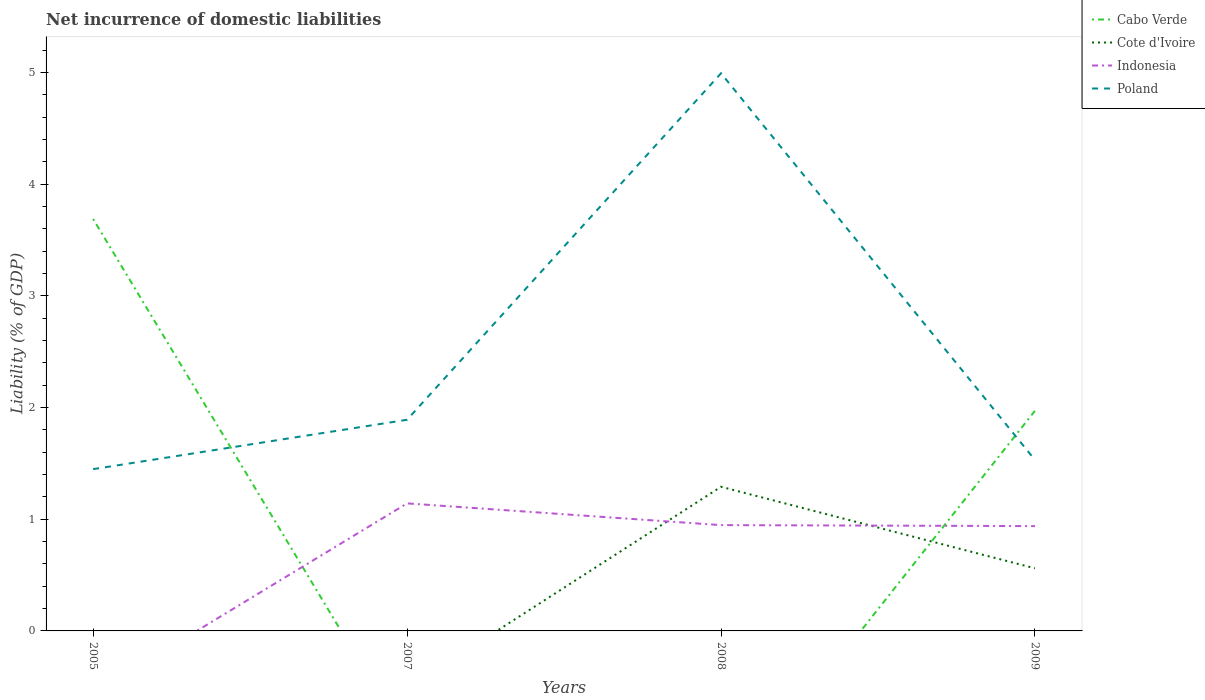How many different coloured lines are there?
Offer a terse response. 4. Is the number of lines equal to the number of legend labels?
Give a very brief answer. No. Across all years, what is the maximum net incurrence of domestic liabilities in Poland?
Make the answer very short. 1.45. What is the total net incurrence of domestic liabilities in Indonesia in the graph?
Your response must be concise. 0.19. What is the difference between the highest and the second highest net incurrence of domestic liabilities in Cote d'Ivoire?
Your answer should be very brief. 1.29. What is the difference between the highest and the lowest net incurrence of domestic liabilities in Cabo Verde?
Make the answer very short. 2. How many years are there in the graph?
Keep it short and to the point. 4. Does the graph contain grids?
Ensure brevity in your answer.  No. What is the title of the graph?
Give a very brief answer. Net incurrence of domestic liabilities. Does "Bangladesh" appear as one of the legend labels in the graph?
Provide a short and direct response. No. What is the label or title of the Y-axis?
Give a very brief answer. Liability (% of GDP). What is the Liability (% of GDP) in Cabo Verde in 2005?
Keep it short and to the point. 3.69. What is the Liability (% of GDP) of Indonesia in 2005?
Make the answer very short. 0. What is the Liability (% of GDP) in Poland in 2005?
Offer a terse response. 1.45. What is the Liability (% of GDP) of Indonesia in 2007?
Provide a succinct answer. 1.14. What is the Liability (% of GDP) in Poland in 2007?
Your answer should be compact. 1.89. What is the Liability (% of GDP) in Cabo Verde in 2008?
Give a very brief answer. 0. What is the Liability (% of GDP) of Cote d'Ivoire in 2008?
Offer a very short reply. 1.29. What is the Liability (% of GDP) in Indonesia in 2008?
Give a very brief answer. 0.95. What is the Liability (% of GDP) of Poland in 2008?
Keep it short and to the point. 4.99. What is the Liability (% of GDP) in Cabo Verde in 2009?
Your answer should be compact. 1.97. What is the Liability (% of GDP) of Cote d'Ivoire in 2009?
Provide a short and direct response. 0.56. What is the Liability (% of GDP) of Indonesia in 2009?
Make the answer very short. 0.94. What is the Liability (% of GDP) in Poland in 2009?
Provide a short and direct response. 1.53. Across all years, what is the maximum Liability (% of GDP) of Cabo Verde?
Keep it short and to the point. 3.69. Across all years, what is the maximum Liability (% of GDP) in Cote d'Ivoire?
Your answer should be compact. 1.29. Across all years, what is the maximum Liability (% of GDP) in Indonesia?
Your answer should be very brief. 1.14. Across all years, what is the maximum Liability (% of GDP) in Poland?
Provide a short and direct response. 4.99. Across all years, what is the minimum Liability (% of GDP) in Cote d'Ivoire?
Ensure brevity in your answer.  0. Across all years, what is the minimum Liability (% of GDP) of Indonesia?
Make the answer very short. 0. Across all years, what is the minimum Liability (% of GDP) in Poland?
Keep it short and to the point. 1.45. What is the total Liability (% of GDP) in Cabo Verde in the graph?
Offer a terse response. 5.66. What is the total Liability (% of GDP) of Cote d'Ivoire in the graph?
Provide a succinct answer. 1.85. What is the total Liability (% of GDP) in Indonesia in the graph?
Offer a very short reply. 3.03. What is the total Liability (% of GDP) in Poland in the graph?
Make the answer very short. 9.86. What is the difference between the Liability (% of GDP) in Poland in 2005 and that in 2007?
Your answer should be very brief. -0.44. What is the difference between the Liability (% of GDP) of Poland in 2005 and that in 2008?
Offer a terse response. -3.54. What is the difference between the Liability (% of GDP) of Cabo Verde in 2005 and that in 2009?
Ensure brevity in your answer.  1.72. What is the difference between the Liability (% of GDP) in Poland in 2005 and that in 2009?
Give a very brief answer. -0.08. What is the difference between the Liability (% of GDP) of Indonesia in 2007 and that in 2008?
Your response must be concise. 0.19. What is the difference between the Liability (% of GDP) in Poland in 2007 and that in 2008?
Provide a short and direct response. -3.1. What is the difference between the Liability (% of GDP) in Indonesia in 2007 and that in 2009?
Your answer should be compact. 0.2. What is the difference between the Liability (% of GDP) of Poland in 2007 and that in 2009?
Your response must be concise. 0.36. What is the difference between the Liability (% of GDP) in Cote d'Ivoire in 2008 and that in 2009?
Make the answer very short. 0.73. What is the difference between the Liability (% of GDP) in Indonesia in 2008 and that in 2009?
Your answer should be compact. 0.01. What is the difference between the Liability (% of GDP) in Poland in 2008 and that in 2009?
Give a very brief answer. 3.46. What is the difference between the Liability (% of GDP) of Cabo Verde in 2005 and the Liability (% of GDP) of Indonesia in 2007?
Provide a short and direct response. 2.55. What is the difference between the Liability (% of GDP) of Cabo Verde in 2005 and the Liability (% of GDP) of Poland in 2007?
Your answer should be very brief. 1.8. What is the difference between the Liability (% of GDP) in Cabo Verde in 2005 and the Liability (% of GDP) in Cote d'Ivoire in 2008?
Make the answer very short. 2.4. What is the difference between the Liability (% of GDP) in Cabo Verde in 2005 and the Liability (% of GDP) in Indonesia in 2008?
Keep it short and to the point. 2.74. What is the difference between the Liability (% of GDP) in Cabo Verde in 2005 and the Liability (% of GDP) in Poland in 2008?
Provide a short and direct response. -1.3. What is the difference between the Liability (% of GDP) in Cabo Verde in 2005 and the Liability (% of GDP) in Cote d'Ivoire in 2009?
Provide a short and direct response. 3.13. What is the difference between the Liability (% of GDP) in Cabo Verde in 2005 and the Liability (% of GDP) in Indonesia in 2009?
Keep it short and to the point. 2.75. What is the difference between the Liability (% of GDP) in Cabo Verde in 2005 and the Liability (% of GDP) in Poland in 2009?
Keep it short and to the point. 2.16. What is the difference between the Liability (% of GDP) of Indonesia in 2007 and the Liability (% of GDP) of Poland in 2008?
Your answer should be very brief. -3.85. What is the difference between the Liability (% of GDP) of Indonesia in 2007 and the Liability (% of GDP) of Poland in 2009?
Provide a succinct answer. -0.39. What is the difference between the Liability (% of GDP) in Cote d'Ivoire in 2008 and the Liability (% of GDP) in Indonesia in 2009?
Provide a short and direct response. 0.35. What is the difference between the Liability (% of GDP) of Cote d'Ivoire in 2008 and the Liability (% of GDP) of Poland in 2009?
Make the answer very short. -0.24. What is the difference between the Liability (% of GDP) in Indonesia in 2008 and the Liability (% of GDP) in Poland in 2009?
Ensure brevity in your answer.  -0.58. What is the average Liability (% of GDP) in Cabo Verde per year?
Your response must be concise. 1.41. What is the average Liability (% of GDP) in Cote d'Ivoire per year?
Keep it short and to the point. 0.46. What is the average Liability (% of GDP) in Indonesia per year?
Your response must be concise. 0.76. What is the average Liability (% of GDP) of Poland per year?
Provide a succinct answer. 2.47. In the year 2005, what is the difference between the Liability (% of GDP) of Cabo Verde and Liability (% of GDP) of Poland?
Your answer should be compact. 2.24. In the year 2007, what is the difference between the Liability (% of GDP) of Indonesia and Liability (% of GDP) of Poland?
Keep it short and to the point. -0.75. In the year 2008, what is the difference between the Liability (% of GDP) of Cote d'Ivoire and Liability (% of GDP) of Indonesia?
Your answer should be very brief. 0.34. In the year 2008, what is the difference between the Liability (% of GDP) of Cote d'Ivoire and Liability (% of GDP) of Poland?
Provide a succinct answer. -3.7. In the year 2008, what is the difference between the Liability (% of GDP) in Indonesia and Liability (% of GDP) in Poland?
Provide a succinct answer. -4.05. In the year 2009, what is the difference between the Liability (% of GDP) of Cabo Verde and Liability (% of GDP) of Cote d'Ivoire?
Your answer should be very brief. 1.41. In the year 2009, what is the difference between the Liability (% of GDP) of Cabo Verde and Liability (% of GDP) of Indonesia?
Provide a short and direct response. 1.03. In the year 2009, what is the difference between the Liability (% of GDP) in Cabo Verde and Liability (% of GDP) in Poland?
Your answer should be compact. 0.44. In the year 2009, what is the difference between the Liability (% of GDP) of Cote d'Ivoire and Liability (% of GDP) of Indonesia?
Your answer should be very brief. -0.38. In the year 2009, what is the difference between the Liability (% of GDP) in Cote d'Ivoire and Liability (% of GDP) in Poland?
Your answer should be compact. -0.97. In the year 2009, what is the difference between the Liability (% of GDP) of Indonesia and Liability (% of GDP) of Poland?
Your response must be concise. -0.59. What is the ratio of the Liability (% of GDP) in Poland in 2005 to that in 2007?
Offer a very short reply. 0.77. What is the ratio of the Liability (% of GDP) of Poland in 2005 to that in 2008?
Your response must be concise. 0.29. What is the ratio of the Liability (% of GDP) in Cabo Verde in 2005 to that in 2009?
Ensure brevity in your answer.  1.87. What is the ratio of the Liability (% of GDP) of Poland in 2005 to that in 2009?
Keep it short and to the point. 0.95. What is the ratio of the Liability (% of GDP) of Indonesia in 2007 to that in 2008?
Offer a terse response. 1.21. What is the ratio of the Liability (% of GDP) in Poland in 2007 to that in 2008?
Ensure brevity in your answer.  0.38. What is the ratio of the Liability (% of GDP) in Indonesia in 2007 to that in 2009?
Make the answer very short. 1.22. What is the ratio of the Liability (% of GDP) in Poland in 2007 to that in 2009?
Offer a very short reply. 1.24. What is the ratio of the Liability (% of GDP) in Cote d'Ivoire in 2008 to that in 2009?
Your response must be concise. 2.3. What is the ratio of the Liability (% of GDP) in Indonesia in 2008 to that in 2009?
Offer a terse response. 1.01. What is the ratio of the Liability (% of GDP) of Poland in 2008 to that in 2009?
Keep it short and to the point. 3.26. What is the difference between the highest and the second highest Liability (% of GDP) in Indonesia?
Keep it short and to the point. 0.19. What is the difference between the highest and the second highest Liability (% of GDP) in Poland?
Your answer should be very brief. 3.1. What is the difference between the highest and the lowest Liability (% of GDP) in Cabo Verde?
Keep it short and to the point. 3.69. What is the difference between the highest and the lowest Liability (% of GDP) of Cote d'Ivoire?
Offer a very short reply. 1.29. What is the difference between the highest and the lowest Liability (% of GDP) in Indonesia?
Give a very brief answer. 1.14. What is the difference between the highest and the lowest Liability (% of GDP) of Poland?
Your answer should be very brief. 3.54. 